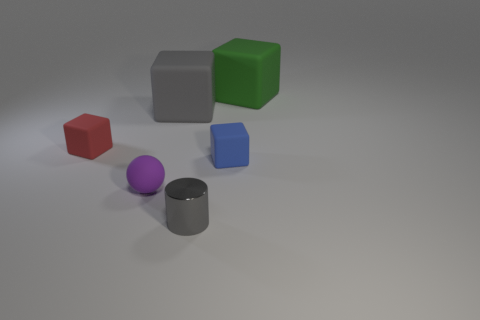What color is the small metal cylinder?
Give a very brief answer. Gray. What is the color of the tiny thing that is both on the left side of the metallic cylinder and behind the small purple rubber object?
Make the answer very short. Red. The small cube behind the tiny block to the right of the tiny thing in front of the purple object is what color?
Provide a short and direct response. Red. There is another metal thing that is the same size as the purple thing; what is its color?
Keep it short and to the point. Gray. What shape is the rubber object in front of the tiny block on the right side of the small matte block to the left of the gray matte object?
Ensure brevity in your answer.  Sphere. What is the shape of the object that is the same color as the cylinder?
Your response must be concise. Cube. What number of objects are either large green cubes or objects in front of the tiny blue matte block?
Your answer should be very brief. 3. There is a cube in front of the red thing; is its size the same as the green matte thing?
Provide a succinct answer. No. There is a thing in front of the purple matte ball; what is it made of?
Your response must be concise. Metal. Are there an equal number of tiny gray objects that are behind the tiny red cube and purple balls behind the big green thing?
Provide a short and direct response. Yes. 